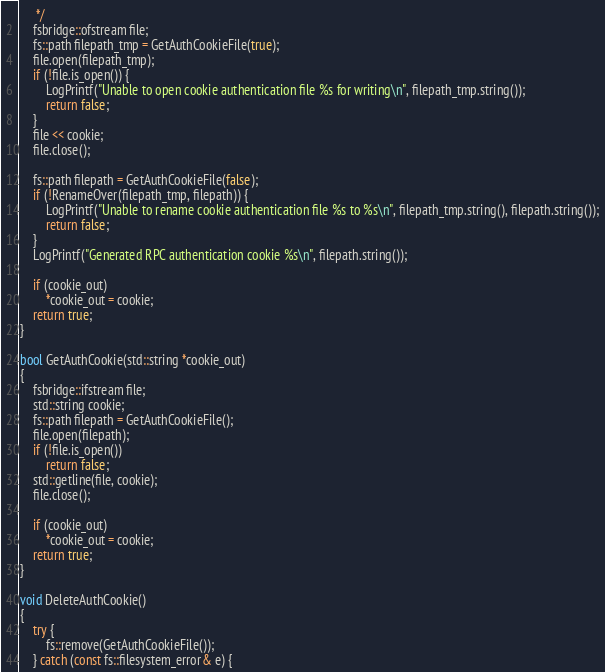<code> <loc_0><loc_0><loc_500><loc_500><_C++_>     */
    fsbridge::ofstream file;
    fs::path filepath_tmp = GetAuthCookieFile(true);
    file.open(filepath_tmp);
    if (!file.is_open()) {
        LogPrintf("Unable to open cookie authentication file %s for writing\n", filepath_tmp.string());
        return false;
    }
    file << cookie;
    file.close();

    fs::path filepath = GetAuthCookieFile(false);
    if (!RenameOver(filepath_tmp, filepath)) {
        LogPrintf("Unable to rename cookie authentication file %s to %s\n", filepath_tmp.string(), filepath.string());
        return false;
    }
    LogPrintf("Generated RPC authentication cookie %s\n", filepath.string());

    if (cookie_out)
        *cookie_out = cookie;
    return true;
}

bool GetAuthCookie(std::string *cookie_out)
{
    fsbridge::ifstream file;
    std::string cookie;
    fs::path filepath = GetAuthCookieFile();
    file.open(filepath);
    if (!file.is_open())
        return false;
    std::getline(file, cookie);
    file.close();

    if (cookie_out)
        *cookie_out = cookie;
    return true;
}

void DeleteAuthCookie()
{
    try {
        fs::remove(GetAuthCookieFile());
    } catch (const fs::filesystem_error& e) {</code> 